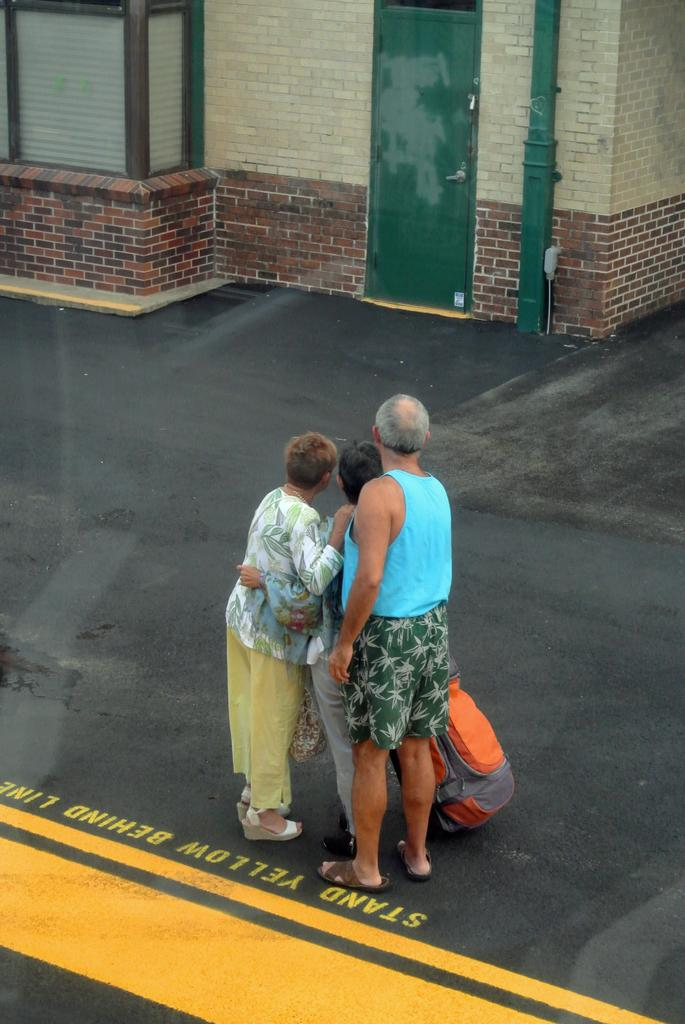How many people are in the image? There are three people in the image. What are the people doing in the image? The people are standing together. What items do the people have with them? The people have luggage with them. What can be seen in the background of the image? There is a building in the background of the image. Can you describe the building in the image? The building has a door and a brick wall. What type of powder can be seen falling from the sky in the image? There is no powder falling from the sky in the image. Can you see a boat in the image? No, there is no boat present in the image. 